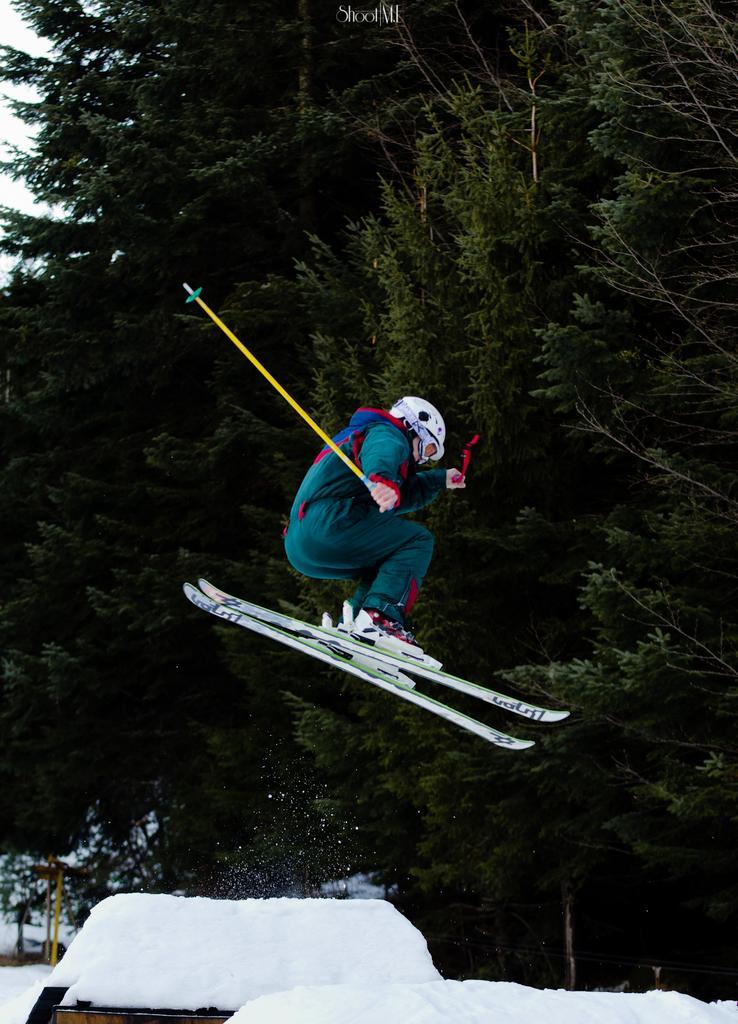Could you give a brief overview of what you see in this image? In this picture I can observe a person standing on the two skiing boards. He is holding yellow color stick in his hand. I can observe some snow on the bottom of the picture. In the background there are trees. 